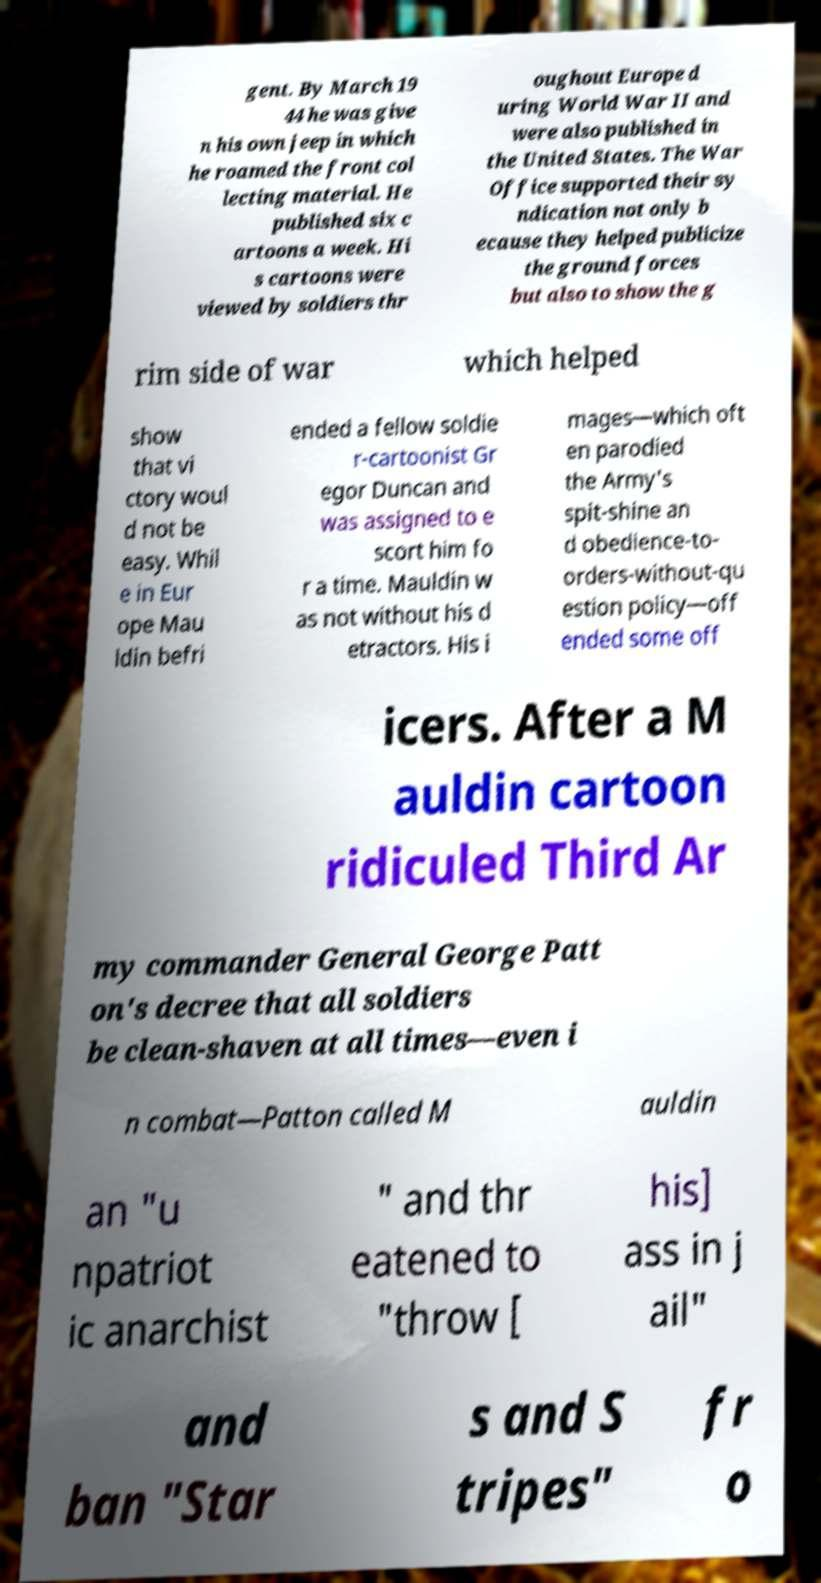Could you extract and type out the text from this image? gent. By March 19 44 he was give n his own jeep in which he roamed the front col lecting material. He published six c artoons a week. Hi s cartoons were viewed by soldiers thr oughout Europe d uring World War II and were also published in the United States. The War Office supported their sy ndication not only b ecause they helped publicize the ground forces but also to show the g rim side of war which helped show that vi ctory woul d not be easy. Whil e in Eur ope Mau ldin befri ended a fellow soldie r-cartoonist Gr egor Duncan and was assigned to e scort him fo r a time. Mauldin w as not without his d etractors. His i mages—which oft en parodied the Army's spit-shine an d obedience-to- orders-without-qu estion policy—off ended some off icers. After a M auldin cartoon ridiculed Third Ar my commander General George Patt on's decree that all soldiers be clean-shaven at all times—even i n combat—Patton called M auldin an "u npatriot ic anarchist " and thr eatened to "throw [ his] ass in j ail" and ban "Star s and S tripes" fr o 